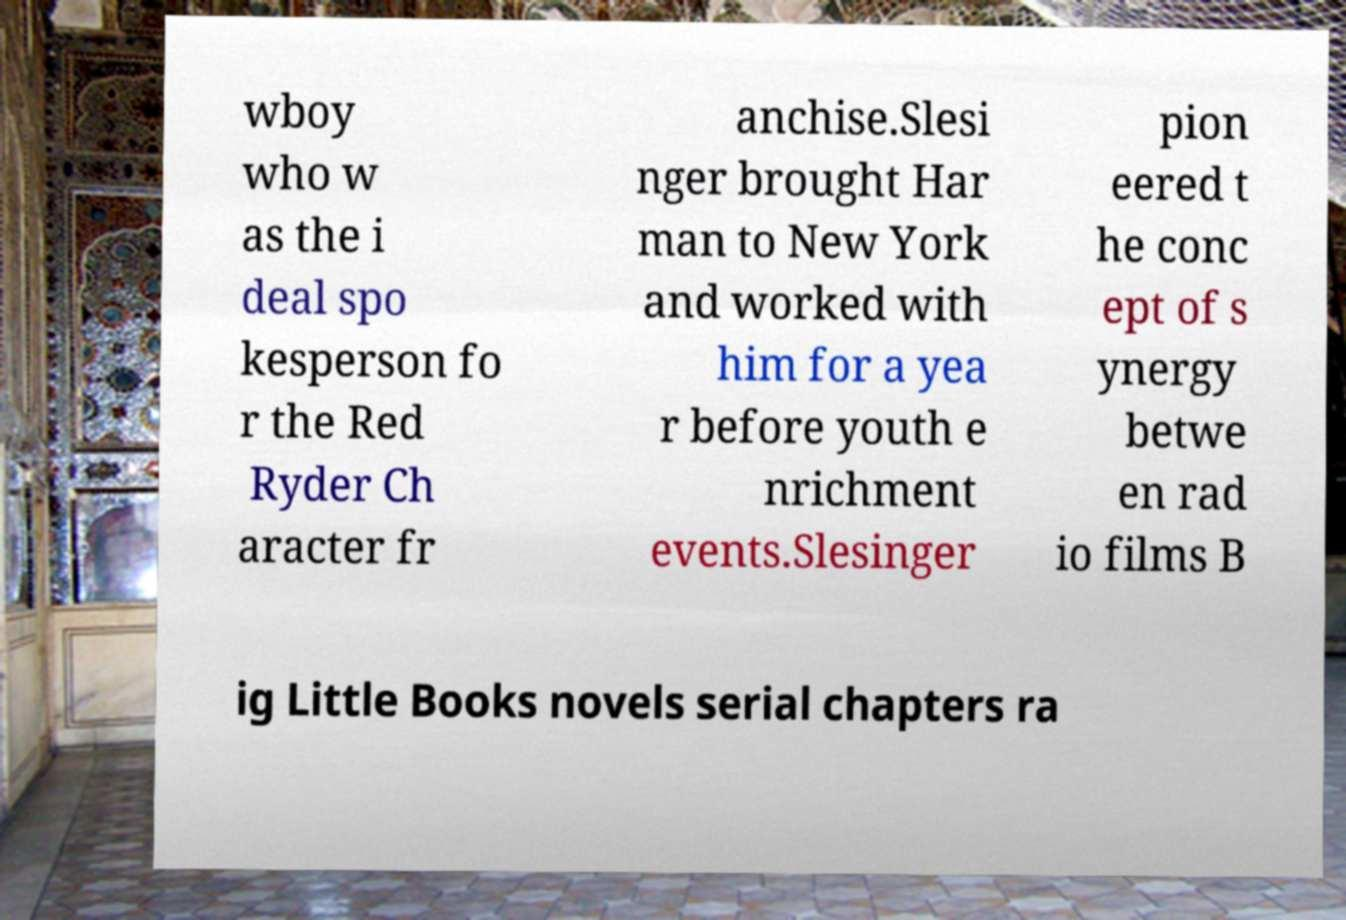I need the written content from this picture converted into text. Can you do that? wboy who w as the i deal spo kesperson fo r the Red Ryder Ch aracter fr anchise.Slesi nger brought Har man to New York and worked with him for a yea r before youth e nrichment events.Slesinger pion eered t he conc ept of s ynergy betwe en rad io films B ig Little Books novels serial chapters ra 